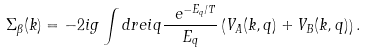<formula> <loc_0><loc_0><loc_500><loc_500>\Sigma _ { \beta } ( k ) = - 2 i g \int d r e i { q } \frac { \ e ^ { - E _ { q } / T } } { E _ { q } } \left ( V _ { A } ( k , q ) + V _ { B } ( k , q ) \right ) .</formula> 